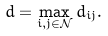Convert formula to latex. <formula><loc_0><loc_0><loc_500><loc_500>d = \max _ { i , j \in \mathcal { N } } d _ { i j } .</formula> 